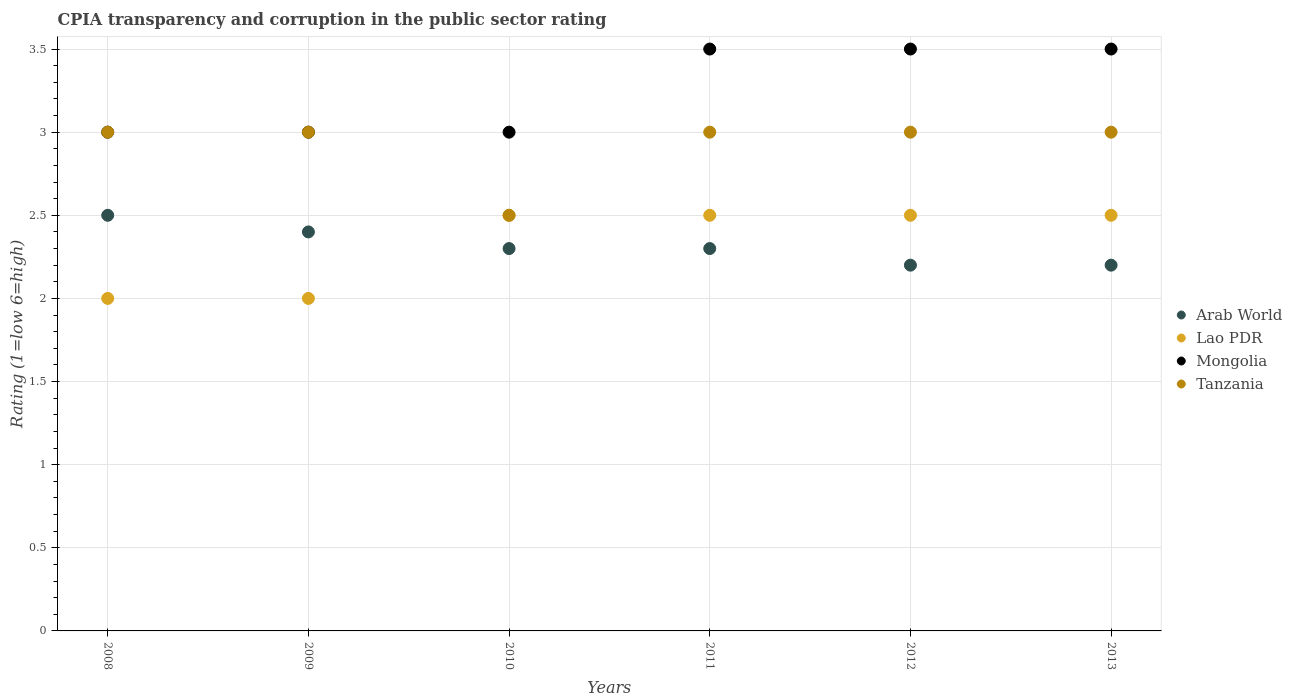How many different coloured dotlines are there?
Ensure brevity in your answer.  4. Is the number of dotlines equal to the number of legend labels?
Your answer should be compact. Yes. What is the CPIA rating in Tanzania in 2010?
Provide a short and direct response. 2.5. Across all years, what is the maximum CPIA rating in Arab World?
Ensure brevity in your answer.  2.5. Across all years, what is the minimum CPIA rating in Mongolia?
Provide a short and direct response. 3. In which year was the CPIA rating in Tanzania maximum?
Offer a very short reply. 2008. In which year was the CPIA rating in Arab World minimum?
Your answer should be compact. 2012. What is the total CPIA rating in Tanzania in the graph?
Offer a very short reply. 17.5. What is the difference between the CPIA rating in Tanzania in 2012 and that in 2013?
Ensure brevity in your answer.  0. What is the average CPIA rating in Lao PDR per year?
Provide a short and direct response. 2.33. In the year 2012, what is the difference between the CPIA rating in Arab World and CPIA rating in Lao PDR?
Offer a terse response. -0.3. In how many years, is the CPIA rating in Tanzania greater than 2.3?
Give a very brief answer. 6. What is the difference between the highest and the lowest CPIA rating in Arab World?
Offer a terse response. 0.3. In how many years, is the CPIA rating in Mongolia greater than the average CPIA rating in Mongolia taken over all years?
Your answer should be very brief. 3. Is the sum of the CPIA rating in Tanzania in 2010 and 2011 greater than the maximum CPIA rating in Lao PDR across all years?
Your answer should be very brief. Yes. Is it the case that in every year, the sum of the CPIA rating in Arab World and CPIA rating in Tanzania  is greater than the sum of CPIA rating in Mongolia and CPIA rating in Lao PDR?
Provide a succinct answer. Yes. Is it the case that in every year, the sum of the CPIA rating in Mongolia and CPIA rating in Arab World  is greater than the CPIA rating in Lao PDR?
Your answer should be compact. Yes. Is the CPIA rating in Tanzania strictly less than the CPIA rating in Mongolia over the years?
Provide a succinct answer. No. How many years are there in the graph?
Your response must be concise. 6. What is the difference between two consecutive major ticks on the Y-axis?
Keep it short and to the point. 0.5. Where does the legend appear in the graph?
Provide a short and direct response. Center right. How many legend labels are there?
Ensure brevity in your answer.  4. What is the title of the graph?
Your answer should be very brief. CPIA transparency and corruption in the public sector rating. Does "Guinea-Bissau" appear as one of the legend labels in the graph?
Offer a very short reply. No. What is the label or title of the X-axis?
Make the answer very short. Years. What is the label or title of the Y-axis?
Give a very brief answer. Rating (1=low 6=high). What is the Rating (1=low 6=high) in Lao PDR in 2008?
Offer a terse response. 2. What is the Rating (1=low 6=high) in Lao PDR in 2009?
Your answer should be very brief. 2. What is the Rating (1=low 6=high) of Mongolia in 2009?
Provide a short and direct response. 3. What is the Rating (1=low 6=high) of Tanzania in 2009?
Make the answer very short. 3. What is the Rating (1=low 6=high) of Arab World in 2010?
Your response must be concise. 2.3. What is the Rating (1=low 6=high) of Mongolia in 2010?
Provide a short and direct response. 3. What is the Rating (1=low 6=high) in Arab World in 2011?
Ensure brevity in your answer.  2.3. What is the Rating (1=low 6=high) in Mongolia in 2011?
Keep it short and to the point. 3.5. What is the Rating (1=low 6=high) in Arab World in 2012?
Keep it short and to the point. 2.2. What is the Rating (1=low 6=high) of Mongolia in 2012?
Ensure brevity in your answer.  3.5. What is the Rating (1=low 6=high) of Tanzania in 2012?
Ensure brevity in your answer.  3. What is the Rating (1=low 6=high) in Arab World in 2013?
Provide a succinct answer. 2.2. What is the Rating (1=low 6=high) of Lao PDR in 2013?
Keep it short and to the point. 2.5. What is the Rating (1=low 6=high) in Mongolia in 2013?
Your answer should be compact. 3.5. Across all years, what is the maximum Rating (1=low 6=high) of Arab World?
Make the answer very short. 2.5. Across all years, what is the maximum Rating (1=low 6=high) in Lao PDR?
Provide a succinct answer. 2.5. Across all years, what is the maximum Rating (1=low 6=high) of Mongolia?
Keep it short and to the point. 3.5. Across all years, what is the minimum Rating (1=low 6=high) of Arab World?
Provide a short and direct response. 2.2. What is the total Rating (1=low 6=high) in Lao PDR in the graph?
Your answer should be very brief. 14. What is the difference between the Rating (1=low 6=high) of Arab World in 2008 and that in 2009?
Ensure brevity in your answer.  0.1. What is the difference between the Rating (1=low 6=high) of Mongolia in 2008 and that in 2009?
Give a very brief answer. 0. What is the difference between the Rating (1=low 6=high) of Lao PDR in 2008 and that in 2010?
Offer a terse response. -0.5. What is the difference between the Rating (1=low 6=high) in Mongolia in 2008 and that in 2010?
Ensure brevity in your answer.  0. What is the difference between the Rating (1=low 6=high) in Lao PDR in 2008 and that in 2011?
Offer a very short reply. -0.5. What is the difference between the Rating (1=low 6=high) of Mongolia in 2008 and that in 2011?
Provide a short and direct response. -0.5. What is the difference between the Rating (1=low 6=high) of Tanzania in 2008 and that in 2011?
Provide a short and direct response. 0. What is the difference between the Rating (1=low 6=high) of Lao PDR in 2008 and that in 2012?
Give a very brief answer. -0.5. What is the difference between the Rating (1=low 6=high) of Tanzania in 2008 and that in 2012?
Keep it short and to the point. 0. What is the difference between the Rating (1=low 6=high) in Lao PDR in 2008 and that in 2013?
Make the answer very short. -0.5. What is the difference between the Rating (1=low 6=high) in Lao PDR in 2009 and that in 2010?
Your response must be concise. -0.5. What is the difference between the Rating (1=low 6=high) of Mongolia in 2009 and that in 2010?
Offer a very short reply. 0. What is the difference between the Rating (1=low 6=high) of Arab World in 2009 and that in 2011?
Your response must be concise. 0.1. What is the difference between the Rating (1=low 6=high) in Lao PDR in 2009 and that in 2011?
Offer a terse response. -0.5. What is the difference between the Rating (1=low 6=high) in Tanzania in 2009 and that in 2011?
Ensure brevity in your answer.  0. What is the difference between the Rating (1=low 6=high) in Arab World in 2009 and that in 2012?
Give a very brief answer. 0.2. What is the difference between the Rating (1=low 6=high) in Mongolia in 2009 and that in 2012?
Keep it short and to the point. -0.5. What is the difference between the Rating (1=low 6=high) of Tanzania in 2009 and that in 2012?
Keep it short and to the point. 0. What is the difference between the Rating (1=low 6=high) in Arab World in 2009 and that in 2013?
Make the answer very short. 0.2. What is the difference between the Rating (1=low 6=high) of Lao PDR in 2009 and that in 2013?
Your answer should be compact. -0.5. What is the difference between the Rating (1=low 6=high) of Arab World in 2010 and that in 2011?
Your response must be concise. 0. What is the difference between the Rating (1=low 6=high) of Lao PDR in 2010 and that in 2011?
Your answer should be very brief. 0. What is the difference between the Rating (1=low 6=high) of Mongolia in 2010 and that in 2011?
Offer a terse response. -0.5. What is the difference between the Rating (1=low 6=high) of Arab World in 2010 and that in 2012?
Provide a succinct answer. 0.1. What is the difference between the Rating (1=low 6=high) of Tanzania in 2010 and that in 2012?
Your answer should be very brief. -0.5. What is the difference between the Rating (1=low 6=high) of Tanzania in 2010 and that in 2013?
Keep it short and to the point. -0.5. What is the difference between the Rating (1=low 6=high) of Arab World in 2011 and that in 2012?
Ensure brevity in your answer.  0.1. What is the difference between the Rating (1=low 6=high) in Tanzania in 2011 and that in 2012?
Your answer should be very brief. 0. What is the difference between the Rating (1=low 6=high) in Arab World in 2011 and that in 2013?
Make the answer very short. 0.1. What is the difference between the Rating (1=low 6=high) in Lao PDR in 2011 and that in 2013?
Your answer should be compact. 0. What is the difference between the Rating (1=low 6=high) in Tanzania in 2011 and that in 2013?
Your answer should be very brief. 0. What is the difference between the Rating (1=low 6=high) of Mongolia in 2012 and that in 2013?
Offer a very short reply. 0. What is the difference between the Rating (1=low 6=high) in Arab World in 2008 and the Rating (1=low 6=high) in Lao PDR in 2009?
Keep it short and to the point. 0.5. What is the difference between the Rating (1=low 6=high) in Arab World in 2008 and the Rating (1=low 6=high) in Mongolia in 2009?
Give a very brief answer. -0.5. What is the difference between the Rating (1=low 6=high) in Lao PDR in 2008 and the Rating (1=low 6=high) in Tanzania in 2009?
Ensure brevity in your answer.  -1. What is the difference between the Rating (1=low 6=high) of Arab World in 2008 and the Rating (1=low 6=high) of Mongolia in 2010?
Your response must be concise. -0.5. What is the difference between the Rating (1=low 6=high) of Arab World in 2008 and the Rating (1=low 6=high) of Tanzania in 2010?
Give a very brief answer. 0. What is the difference between the Rating (1=low 6=high) of Lao PDR in 2008 and the Rating (1=low 6=high) of Mongolia in 2010?
Your response must be concise. -1. What is the difference between the Rating (1=low 6=high) in Mongolia in 2008 and the Rating (1=low 6=high) in Tanzania in 2010?
Make the answer very short. 0.5. What is the difference between the Rating (1=low 6=high) in Arab World in 2008 and the Rating (1=low 6=high) in Lao PDR in 2011?
Give a very brief answer. 0. What is the difference between the Rating (1=low 6=high) in Lao PDR in 2008 and the Rating (1=low 6=high) in Mongolia in 2011?
Your response must be concise. -1.5. What is the difference between the Rating (1=low 6=high) in Arab World in 2008 and the Rating (1=low 6=high) in Lao PDR in 2012?
Provide a short and direct response. 0. What is the difference between the Rating (1=low 6=high) of Arab World in 2008 and the Rating (1=low 6=high) of Mongolia in 2012?
Offer a terse response. -1. What is the difference between the Rating (1=low 6=high) of Arab World in 2008 and the Rating (1=low 6=high) of Tanzania in 2012?
Make the answer very short. -0.5. What is the difference between the Rating (1=low 6=high) in Lao PDR in 2008 and the Rating (1=low 6=high) in Tanzania in 2012?
Provide a short and direct response. -1. What is the difference between the Rating (1=low 6=high) of Mongolia in 2008 and the Rating (1=low 6=high) of Tanzania in 2012?
Your response must be concise. 0. What is the difference between the Rating (1=low 6=high) in Arab World in 2008 and the Rating (1=low 6=high) in Lao PDR in 2013?
Offer a very short reply. 0. What is the difference between the Rating (1=low 6=high) of Arab World in 2008 and the Rating (1=low 6=high) of Mongolia in 2013?
Offer a very short reply. -1. What is the difference between the Rating (1=low 6=high) in Lao PDR in 2008 and the Rating (1=low 6=high) in Mongolia in 2013?
Your response must be concise. -1.5. What is the difference between the Rating (1=low 6=high) in Lao PDR in 2008 and the Rating (1=low 6=high) in Tanzania in 2013?
Make the answer very short. -1. What is the difference between the Rating (1=low 6=high) of Arab World in 2009 and the Rating (1=low 6=high) of Mongolia in 2010?
Ensure brevity in your answer.  -0.6. What is the difference between the Rating (1=low 6=high) in Arab World in 2009 and the Rating (1=low 6=high) in Tanzania in 2010?
Ensure brevity in your answer.  -0.1. What is the difference between the Rating (1=low 6=high) of Lao PDR in 2009 and the Rating (1=low 6=high) of Mongolia in 2010?
Keep it short and to the point. -1. What is the difference between the Rating (1=low 6=high) of Lao PDR in 2009 and the Rating (1=low 6=high) of Tanzania in 2010?
Provide a short and direct response. -0.5. What is the difference between the Rating (1=low 6=high) of Arab World in 2009 and the Rating (1=low 6=high) of Mongolia in 2011?
Your answer should be compact. -1.1. What is the difference between the Rating (1=low 6=high) of Arab World in 2009 and the Rating (1=low 6=high) of Tanzania in 2011?
Make the answer very short. -0.6. What is the difference between the Rating (1=low 6=high) of Mongolia in 2009 and the Rating (1=low 6=high) of Tanzania in 2011?
Offer a terse response. 0. What is the difference between the Rating (1=low 6=high) in Arab World in 2009 and the Rating (1=low 6=high) in Mongolia in 2012?
Keep it short and to the point. -1.1. What is the difference between the Rating (1=low 6=high) in Arab World in 2009 and the Rating (1=low 6=high) in Tanzania in 2012?
Provide a short and direct response. -0.6. What is the difference between the Rating (1=low 6=high) in Lao PDR in 2009 and the Rating (1=low 6=high) in Mongolia in 2012?
Offer a terse response. -1.5. What is the difference between the Rating (1=low 6=high) of Lao PDR in 2009 and the Rating (1=low 6=high) of Tanzania in 2012?
Your answer should be very brief. -1. What is the difference between the Rating (1=low 6=high) of Mongolia in 2009 and the Rating (1=low 6=high) of Tanzania in 2012?
Your response must be concise. 0. What is the difference between the Rating (1=low 6=high) of Arab World in 2009 and the Rating (1=low 6=high) of Lao PDR in 2013?
Offer a very short reply. -0.1. What is the difference between the Rating (1=low 6=high) in Arab World in 2009 and the Rating (1=low 6=high) in Tanzania in 2013?
Provide a short and direct response. -0.6. What is the difference between the Rating (1=low 6=high) in Lao PDR in 2009 and the Rating (1=low 6=high) in Tanzania in 2013?
Your response must be concise. -1. What is the difference between the Rating (1=low 6=high) of Arab World in 2010 and the Rating (1=low 6=high) of Lao PDR in 2011?
Ensure brevity in your answer.  -0.2. What is the difference between the Rating (1=low 6=high) of Arab World in 2010 and the Rating (1=low 6=high) of Mongolia in 2011?
Give a very brief answer. -1.2. What is the difference between the Rating (1=low 6=high) in Lao PDR in 2010 and the Rating (1=low 6=high) in Mongolia in 2011?
Offer a very short reply. -1. What is the difference between the Rating (1=low 6=high) of Mongolia in 2010 and the Rating (1=low 6=high) of Tanzania in 2011?
Provide a short and direct response. 0. What is the difference between the Rating (1=low 6=high) of Arab World in 2010 and the Rating (1=low 6=high) of Lao PDR in 2013?
Provide a succinct answer. -0.2. What is the difference between the Rating (1=low 6=high) of Arab World in 2010 and the Rating (1=low 6=high) of Mongolia in 2013?
Make the answer very short. -1.2. What is the difference between the Rating (1=low 6=high) in Lao PDR in 2010 and the Rating (1=low 6=high) in Mongolia in 2013?
Keep it short and to the point. -1. What is the difference between the Rating (1=low 6=high) in Arab World in 2011 and the Rating (1=low 6=high) in Mongolia in 2012?
Offer a very short reply. -1.2. What is the difference between the Rating (1=low 6=high) in Lao PDR in 2011 and the Rating (1=low 6=high) in Mongolia in 2012?
Your response must be concise. -1. What is the difference between the Rating (1=low 6=high) in Mongolia in 2011 and the Rating (1=low 6=high) in Tanzania in 2012?
Give a very brief answer. 0.5. What is the difference between the Rating (1=low 6=high) of Arab World in 2011 and the Rating (1=low 6=high) of Lao PDR in 2013?
Offer a very short reply. -0.2. What is the difference between the Rating (1=low 6=high) in Arab World in 2011 and the Rating (1=low 6=high) in Mongolia in 2013?
Make the answer very short. -1.2. What is the difference between the Rating (1=low 6=high) in Arab World in 2011 and the Rating (1=low 6=high) in Tanzania in 2013?
Offer a terse response. -0.7. What is the difference between the Rating (1=low 6=high) of Lao PDR in 2011 and the Rating (1=low 6=high) of Mongolia in 2013?
Offer a very short reply. -1. What is the difference between the Rating (1=low 6=high) of Lao PDR in 2011 and the Rating (1=low 6=high) of Tanzania in 2013?
Give a very brief answer. -0.5. What is the difference between the Rating (1=low 6=high) of Arab World in 2012 and the Rating (1=low 6=high) of Tanzania in 2013?
Your response must be concise. -0.8. What is the difference between the Rating (1=low 6=high) in Lao PDR in 2012 and the Rating (1=low 6=high) in Tanzania in 2013?
Offer a very short reply. -0.5. What is the difference between the Rating (1=low 6=high) in Mongolia in 2012 and the Rating (1=low 6=high) in Tanzania in 2013?
Make the answer very short. 0.5. What is the average Rating (1=low 6=high) of Arab World per year?
Make the answer very short. 2.32. What is the average Rating (1=low 6=high) of Lao PDR per year?
Provide a succinct answer. 2.33. What is the average Rating (1=low 6=high) of Mongolia per year?
Your response must be concise. 3.25. What is the average Rating (1=low 6=high) of Tanzania per year?
Your answer should be compact. 2.92. In the year 2008, what is the difference between the Rating (1=low 6=high) in Arab World and Rating (1=low 6=high) in Mongolia?
Offer a very short reply. -0.5. In the year 2008, what is the difference between the Rating (1=low 6=high) of Lao PDR and Rating (1=low 6=high) of Mongolia?
Offer a terse response. -1. In the year 2008, what is the difference between the Rating (1=low 6=high) of Lao PDR and Rating (1=low 6=high) of Tanzania?
Your response must be concise. -1. In the year 2008, what is the difference between the Rating (1=low 6=high) in Mongolia and Rating (1=low 6=high) in Tanzania?
Offer a very short reply. 0. In the year 2009, what is the difference between the Rating (1=low 6=high) in Arab World and Rating (1=low 6=high) in Lao PDR?
Your response must be concise. 0.4. In the year 2009, what is the difference between the Rating (1=low 6=high) of Arab World and Rating (1=low 6=high) of Mongolia?
Provide a short and direct response. -0.6. In the year 2009, what is the difference between the Rating (1=low 6=high) in Lao PDR and Rating (1=low 6=high) in Mongolia?
Your answer should be very brief. -1. In the year 2009, what is the difference between the Rating (1=low 6=high) in Mongolia and Rating (1=low 6=high) in Tanzania?
Provide a succinct answer. 0. In the year 2010, what is the difference between the Rating (1=low 6=high) of Arab World and Rating (1=low 6=high) of Mongolia?
Make the answer very short. -0.7. In the year 2010, what is the difference between the Rating (1=low 6=high) in Lao PDR and Rating (1=low 6=high) in Mongolia?
Give a very brief answer. -0.5. In the year 2010, what is the difference between the Rating (1=low 6=high) of Mongolia and Rating (1=low 6=high) of Tanzania?
Keep it short and to the point. 0.5. In the year 2011, what is the difference between the Rating (1=low 6=high) of Arab World and Rating (1=low 6=high) of Lao PDR?
Your answer should be very brief. -0.2. In the year 2012, what is the difference between the Rating (1=low 6=high) of Arab World and Rating (1=low 6=high) of Lao PDR?
Offer a terse response. -0.3. In the year 2012, what is the difference between the Rating (1=low 6=high) of Arab World and Rating (1=low 6=high) of Tanzania?
Your answer should be very brief. -0.8. In the year 2012, what is the difference between the Rating (1=low 6=high) in Lao PDR and Rating (1=low 6=high) in Tanzania?
Offer a very short reply. -0.5. In the year 2012, what is the difference between the Rating (1=low 6=high) in Mongolia and Rating (1=low 6=high) in Tanzania?
Your answer should be compact. 0.5. In the year 2013, what is the difference between the Rating (1=low 6=high) of Arab World and Rating (1=low 6=high) of Lao PDR?
Ensure brevity in your answer.  -0.3. In the year 2013, what is the difference between the Rating (1=low 6=high) in Arab World and Rating (1=low 6=high) in Mongolia?
Offer a very short reply. -1.3. In the year 2013, what is the difference between the Rating (1=low 6=high) in Arab World and Rating (1=low 6=high) in Tanzania?
Your answer should be very brief. -0.8. In the year 2013, what is the difference between the Rating (1=low 6=high) of Lao PDR and Rating (1=low 6=high) of Mongolia?
Give a very brief answer. -1. In the year 2013, what is the difference between the Rating (1=low 6=high) in Lao PDR and Rating (1=low 6=high) in Tanzania?
Offer a terse response. -0.5. What is the ratio of the Rating (1=low 6=high) in Arab World in 2008 to that in 2009?
Make the answer very short. 1.04. What is the ratio of the Rating (1=low 6=high) of Lao PDR in 2008 to that in 2009?
Give a very brief answer. 1. What is the ratio of the Rating (1=low 6=high) of Tanzania in 2008 to that in 2009?
Keep it short and to the point. 1. What is the ratio of the Rating (1=low 6=high) in Arab World in 2008 to that in 2010?
Your answer should be compact. 1.09. What is the ratio of the Rating (1=low 6=high) in Tanzania in 2008 to that in 2010?
Provide a succinct answer. 1.2. What is the ratio of the Rating (1=low 6=high) of Arab World in 2008 to that in 2011?
Offer a terse response. 1.09. What is the ratio of the Rating (1=low 6=high) in Mongolia in 2008 to that in 2011?
Offer a very short reply. 0.86. What is the ratio of the Rating (1=low 6=high) of Tanzania in 2008 to that in 2011?
Your answer should be compact. 1. What is the ratio of the Rating (1=low 6=high) of Arab World in 2008 to that in 2012?
Keep it short and to the point. 1.14. What is the ratio of the Rating (1=low 6=high) of Lao PDR in 2008 to that in 2012?
Provide a succinct answer. 0.8. What is the ratio of the Rating (1=low 6=high) in Tanzania in 2008 to that in 2012?
Provide a short and direct response. 1. What is the ratio of the Rating (1=low 6=high) of Arab World in 2008 to that in 2013?
Give a very brief answer. 1.14. What is the ratio of the Rating (1=low 6=high) in Lao PDR in 2008 to that in 2013?
Your response must be concise. 0.8. What is the ratio of the Rating (1=low 6=high) of Tanzania in 2008 to that in 2013?
Make the answer very short. 1. What is the ratio of the Rating (1=low 6=high) in Arab World in 2009 to that in 2010?
Your answer should be very brief. 1.04. What is the ratio of the Rating (1=low 6=high) in Arab World in 2009 to that in 2011?
Provide a short and direct response. 1.04. What is the ratio of the Rating (1=low 6=high) of Lao PDR in 2009 to that in 2011?
Your response must be concise. 0.8. What is the ratio of the Rating (1=low 6=high) in Arab World in 2009 to that in 2012?
Give a very brief answer. 1.09. What is the ratio of the Rating (1=low 6=high) in Lao PDR in 2009 to that in 2012?
Offer a very short reply. 0.8. What is the ratio of the Rating (1=low 6=high) in Mongolia in 2009 to that in 2012?
Provide a succinct answer. 0.86. What is the ratio of the Rating (1=low 6=high) in Lao PDR in 2009 to that in 2013?
Keep it short and to the point. 0.8. What is the ratio of the Rating (1=low 6=high) of Mongolia in 2009 to that in 2013?
Keep it short and to the point. 0.86. What is the ratio of the Rating (1=low 6=high) in Arab World in 2010 to that in 2011?
Your answer should be very brief. 1. What is the ratio of the Rating (1=low 6=high) of Lao PDR in 2010 to that in 2011?
Your response must be concise. 1. What is the ratio of the Rating (1=low 6=high) in Mongolia in 2010 to that in 2011?
Give a very brief answer. 0.86. What is the ratio of the Rating (1=low 6=high) in Tanzania in 2010 to that in 2011?
Your response must be concise. 0.83. What is the ratio of the Rating (1=low 6=high) in Arab World in 2010 to that in 2012?
Provide a succinct answer. 1.05. What is the ratio of the Rating (1=low 6=high) of Mongolia in 2010 to that in 2012?
Provide a short and direct response. 0.86. What is the ratio of the Rating (1=low 6=high) in Tanzania in 2010 to that in 2012?
Provide a succinct answer. 0.83. What is the ratio of the Rating (1=low 6=high) of Arab World in 2010 to that in 2013?
Offer a terse response. 1.05. What is the ratio of the Rating (1=low 6=high) in Lao PDR in 2010 to that in 2013?
Ensure brevity in your answer.  1. What is the ratio of the Rating (1=low 6=high) of Mongolia in 2010 to that in 2013?
Give a very brief answer. 0.86. What is the ratio of the Rating (1=low 6=high) of Arab World in 2011 to that in 2012?
Keep it short and to the point. 1.05. What is the ratio of the Rating (1=low 6=high) in Mongolia in 2011 to that in 2012?
Give a very brief answer. 1. What is the ratio of the Rating (1=low 6=high) of Arab World in 2011 to that in 2013?
Make the answer very short. 1.05. What is the ratio of the Rating (1=low 6=high) of Lao PDR in 2011 to that in 2013?
Provide a succinct answer. 1. What is the ratio of the Rating (1=low 6=high) of Mongolia in 2011 to that in 2013?
Make the answer very short. 1. What is the ratio of the Rating (1=low 6=high) in Lao PDR in 2012 to that in 2013?
Make the answer very short. 1. What is the ratio of the Rating (1=low 6=high) of Tanzania in 2012 to that in 2013?
Your answer should be compact. 1. What is the difference between the highest and the second highest Rating (1=low 6=high) in Arab World?
Make the answer very short. 0.1. What is the difference between the highest and the second highest Rating (1=low 6=high) in Mongolia?
Your answer should be compact. 0. What is the difference between the highest and the second highest Rating (1=low 6=high) in Tanzania?
Keep it short and to the point. 0. What is the difference between the highest and the lowest Rating (1=low 6=high) in Lao PDR?
Offer a terse response. 0.5. What is the difference between the highest and the lowest Rating (1=low 6=high) of Mongolia?
Offer a very short reply. 0.5. What is the difference between the highest and the lowest Rating (1=low 6=high) in Tanzania?
Give a very brief answer. 0.5. 